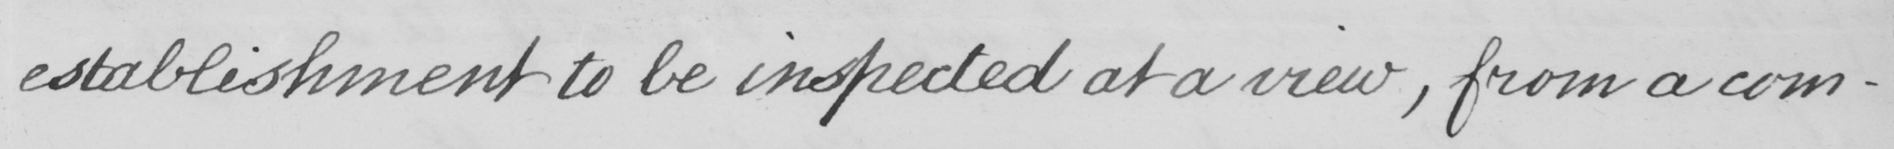Please transcribe the handwritten text in this image. establishment to be inspected at a view , from a com- 